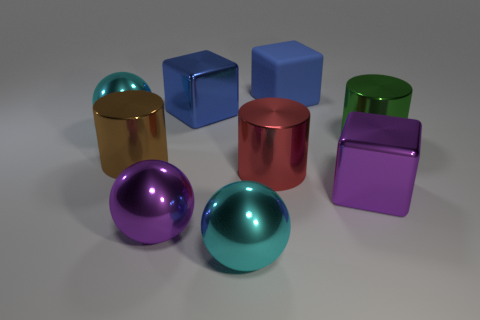How many things are either big brown cylinders behind the big purple shiny block or objects that are in front of the large brown shiny thing?
Keep it short and to the point. 5. There is another large blue thing that is the same shape as the blue metallic thing; what is its material?
Give a very brief answer. Rubber. Is there a blue rubber cube?
Ensure brevity in your answer.  Yes. What shape is the large red shiny object?
Your answer should be very brief. Cylinder. There is a metallic cylinder that is to the left of the large red cylinder; is there a sphere to the right of it?
Ensure brevity in your answer.  Yes. There is a blue object that is the same size as the blue metallic cube; what material is it?
Your answer should be compact. Rubber. Is there a blue matte thing that has the same size as the purple ball?
Provide a succinct answer. Yes. There is a big blue cube right of the red shiny object; what material is it?
Offer a terse response. Rubber. Are the blue thing that is to the right of the big red thing and the big brown object made of the same material?
Offer a very short reply. No. There is a green metal thing that is the same size as the red object; what is its shape?
Your response must be concise. Cylinder. 